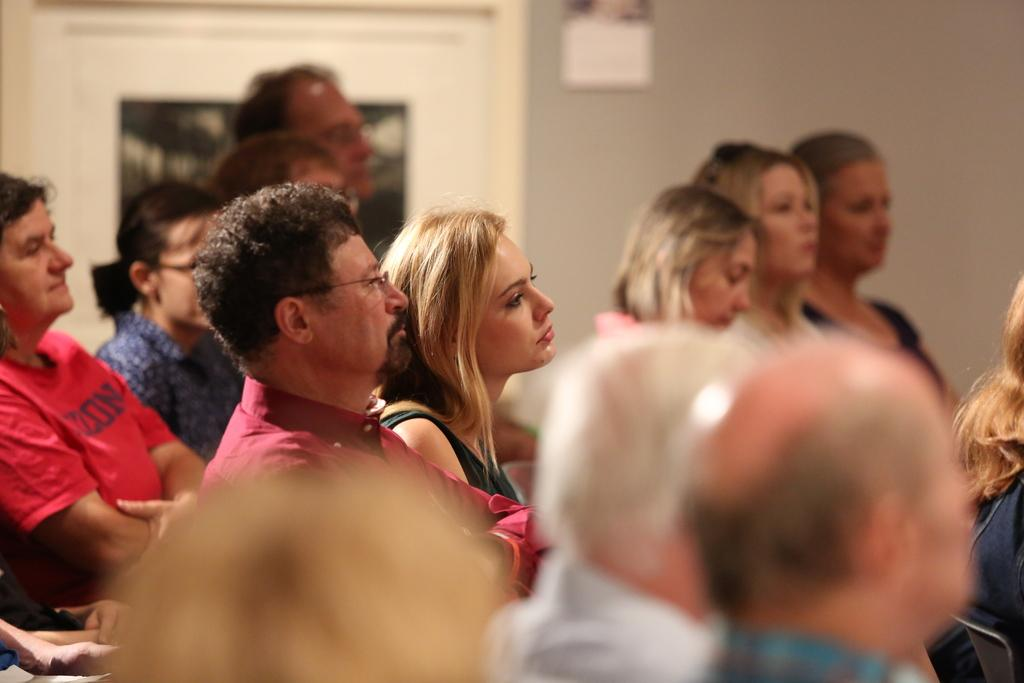How many people are in the image? There is a group of people in the image, but the exact number is not specified. Where are the people located in the image? The people are in a room. What are the people doing in the image? The people are paying attention towards something. What type of stocking is hanging from the ceiling in the image? There is no stocking hanging from the ceiling in the image. 